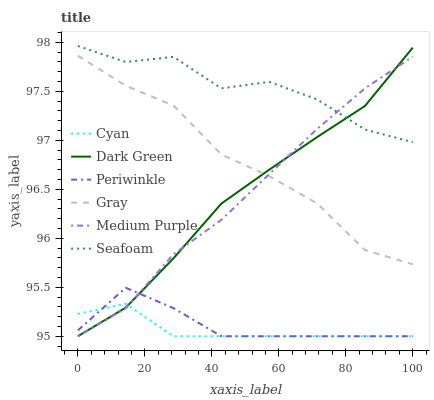Does Cyan have the minimum area under the curve?
Answer yes or no. Yes. Does Seafoam have the maximum area under the curve?
Answer yes or no. Yes. Does Medium Purple have the minimum area under the curve?
Answer yes or no. No. Does Medium Purple have the maximum area under the curve?
Answer yes or no. No. Is Medium Purple the smoothest?
Answer yes or no. Yes. Is Seafoam the roughest?
Answer yes or no. Yes. Is Seafoam the smoothest?
Answer yes or no. No. Is Medium Purple the roughest?
Answer yes or no. No. Does Seafoam have the lowest value?
Answer yes or no. No. Does Medium Purple have the highest value?
Answer yes or no. No. Is Periwinkle less than Seafoam?
Answer yes or no. Yes. Is Seafoam greater than Gray?
Answer yes or no. Yes. Does Periwinkle intersect Seafoam?
Answer yes or no. No. 